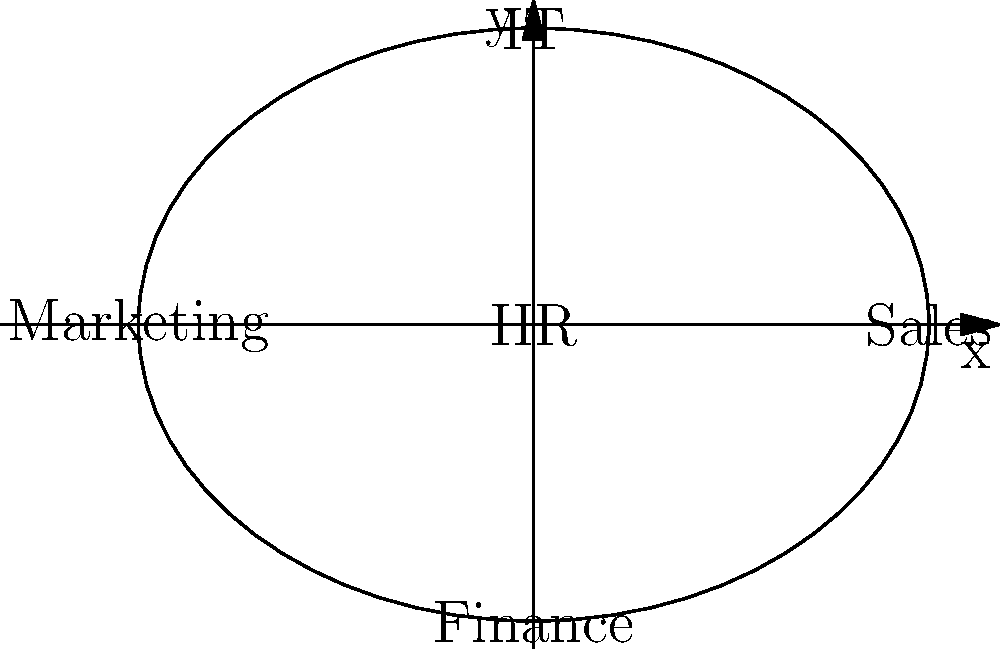A company's organizational structure is represented by an ellipse, where each department's scope is visualized by its position on the ellipse. The semi-major axis (a) is 4 units, and the semi-minor axis (b) is 3 units. Calculate the area of this ellipse to determine the total scope of all departments. How does this geometric representation relate to the ethical distribution of resources and responsibilities across departments? To solve this problem, we'll follow these steps:

1. Recall the formula for the area of an ellipse:
   $$ A = \pi ab $$
   where $a$ is the semi-major axis and $b$ is the semi-minor axis.

2. We are given:
   $a = 4$ units
   $b = 3$ units

3. Substitute these values into the formula:
   $$ A = \pi (4)(3) = 12\pi $$

4. Calculate the final result:
   $$ A = 12\pi \approx 37.70 \text{ square units} $$

5. Ethical considerations:
   - The ellipse represents the company's total scope, with each department positioned at different points.
   - The area (37.70 square units) symbolizes the total resources and responsibilities distributed among departments.
   - The elliptical shape suggests that some departments (along the major axis) may have a broader scope than others (along the minor axis).
   - Ethical distribution would involve ensuring that resources and responsibilities are allocated fairly, considering each department's position and importance.
   - The HR manager should consider how this geometric representation aligns with the company's values and if it promotes a balanced and ethical distribution of resources.
Answer: $12\pi$ square units (≈ 37.70 square units) 